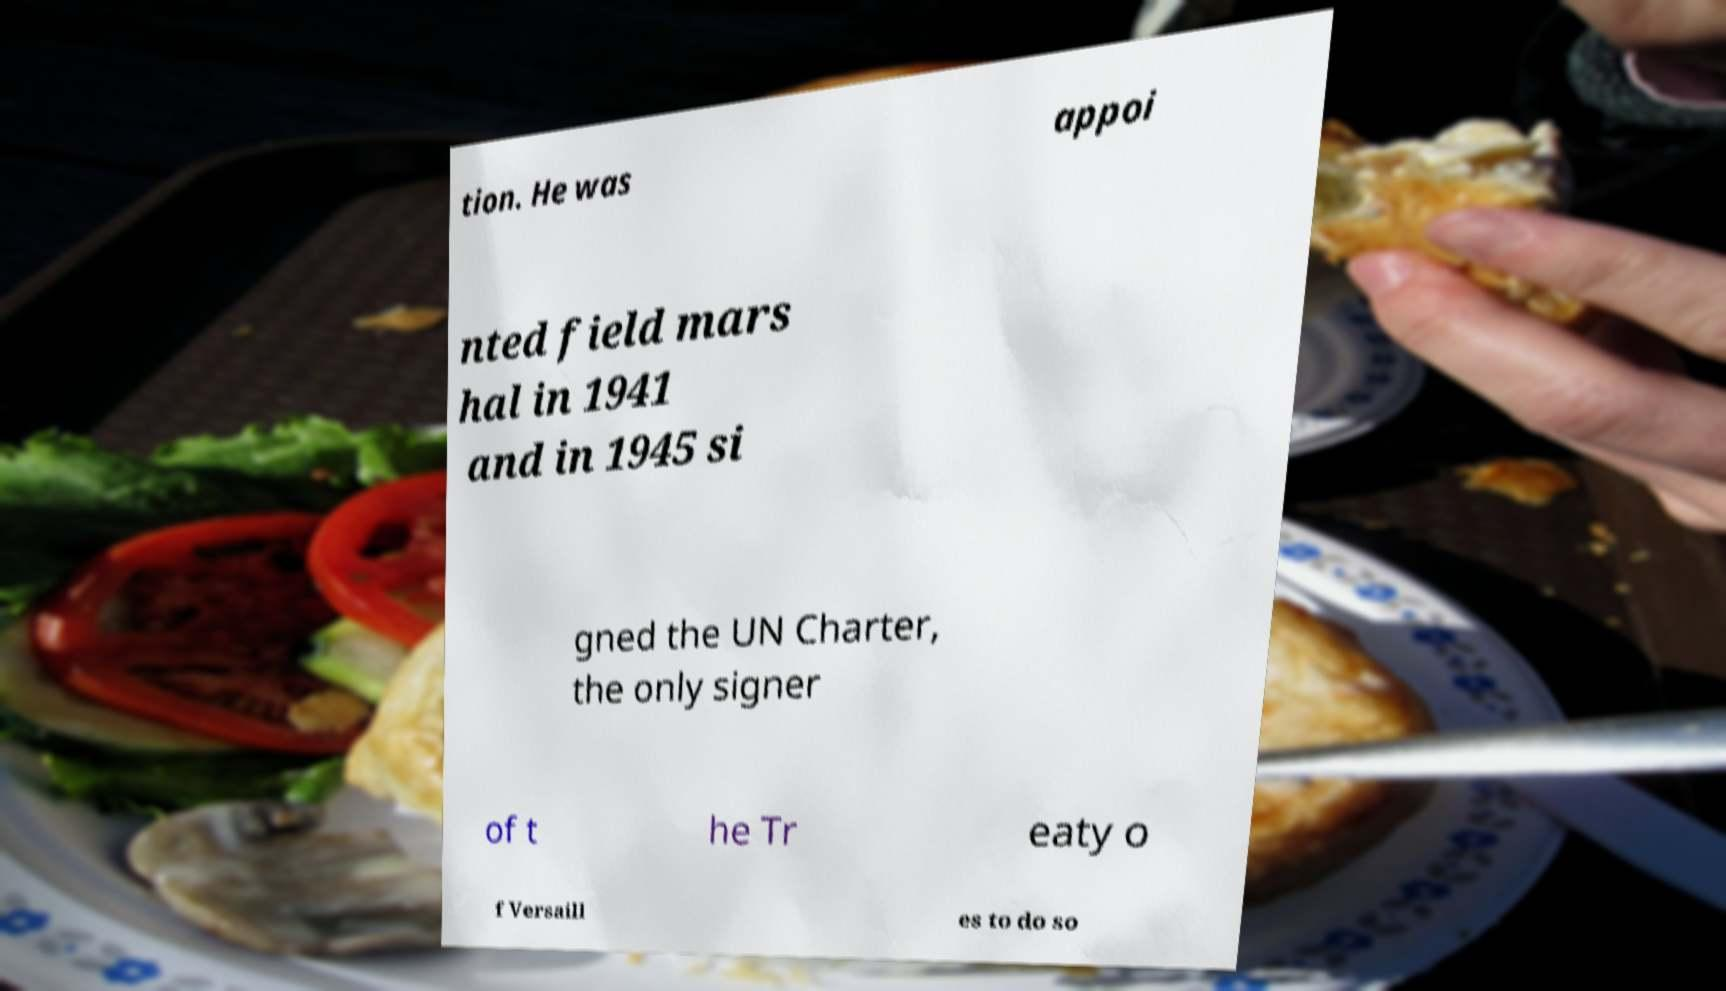What messages or text are displayed in this image? I need them in a readable, typed format. tion. He was appoi nted field mars hal in 1941 and in 1945 si gned the UN Charter, the only signer of t he Tr eaty o f Versaill es to do so 